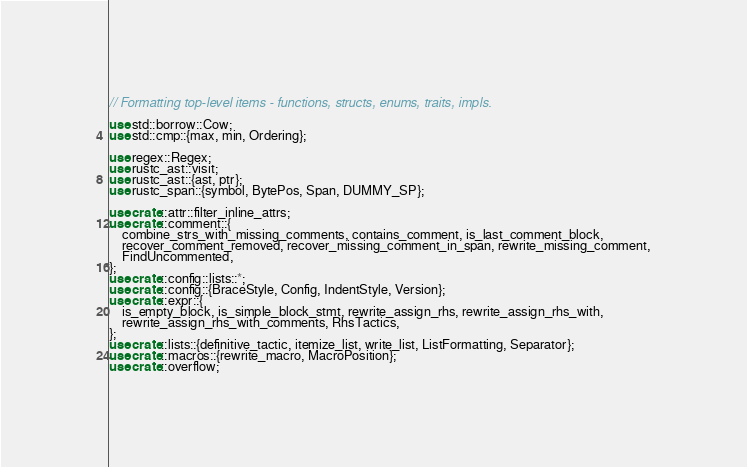Convert code to text. <code><loc_0><loc_0><loc_500><loc_500><_Rust_>// Formatting top-level items - functions, structs, enums, traits, impls.

use std::borrow::Cow;
use std::cmp::{max, min, Ordering};

use regex::Regex;
use rustc_ast::visit;
use rustc_ast::{ast, ptr};
use rustc_span::{symbol, BytePos, Span, DUMMY_SP};

use crate::attr::filter_inline_attrs;
use crate::comment::{
    combine_strs_with_missing_comments, contains_comment, is_last_comment_block,
    recover_comment_removed, recover_missing_comment_in_span, rewrite_missing_comment,
    FindUncommented,
};
use crate::config::lists::*;
use crate::config::{BraceStyle, Config, IndentStyle, Version};
use crate::expr::{
    is_empty_block, is_simple_block_stmt, rewrite_assign_rhs, rewrite_assign_rhs_with,
    rewrite_assign_rhs_with_comments, RhsTactics,
};
use crate::lists::{definitive_tactic, itemize_list, write_list, ListFormatting, Separator};
use crate::macros::{rewrite_macro, MacroPosition};
use crate::overflow;</code> 